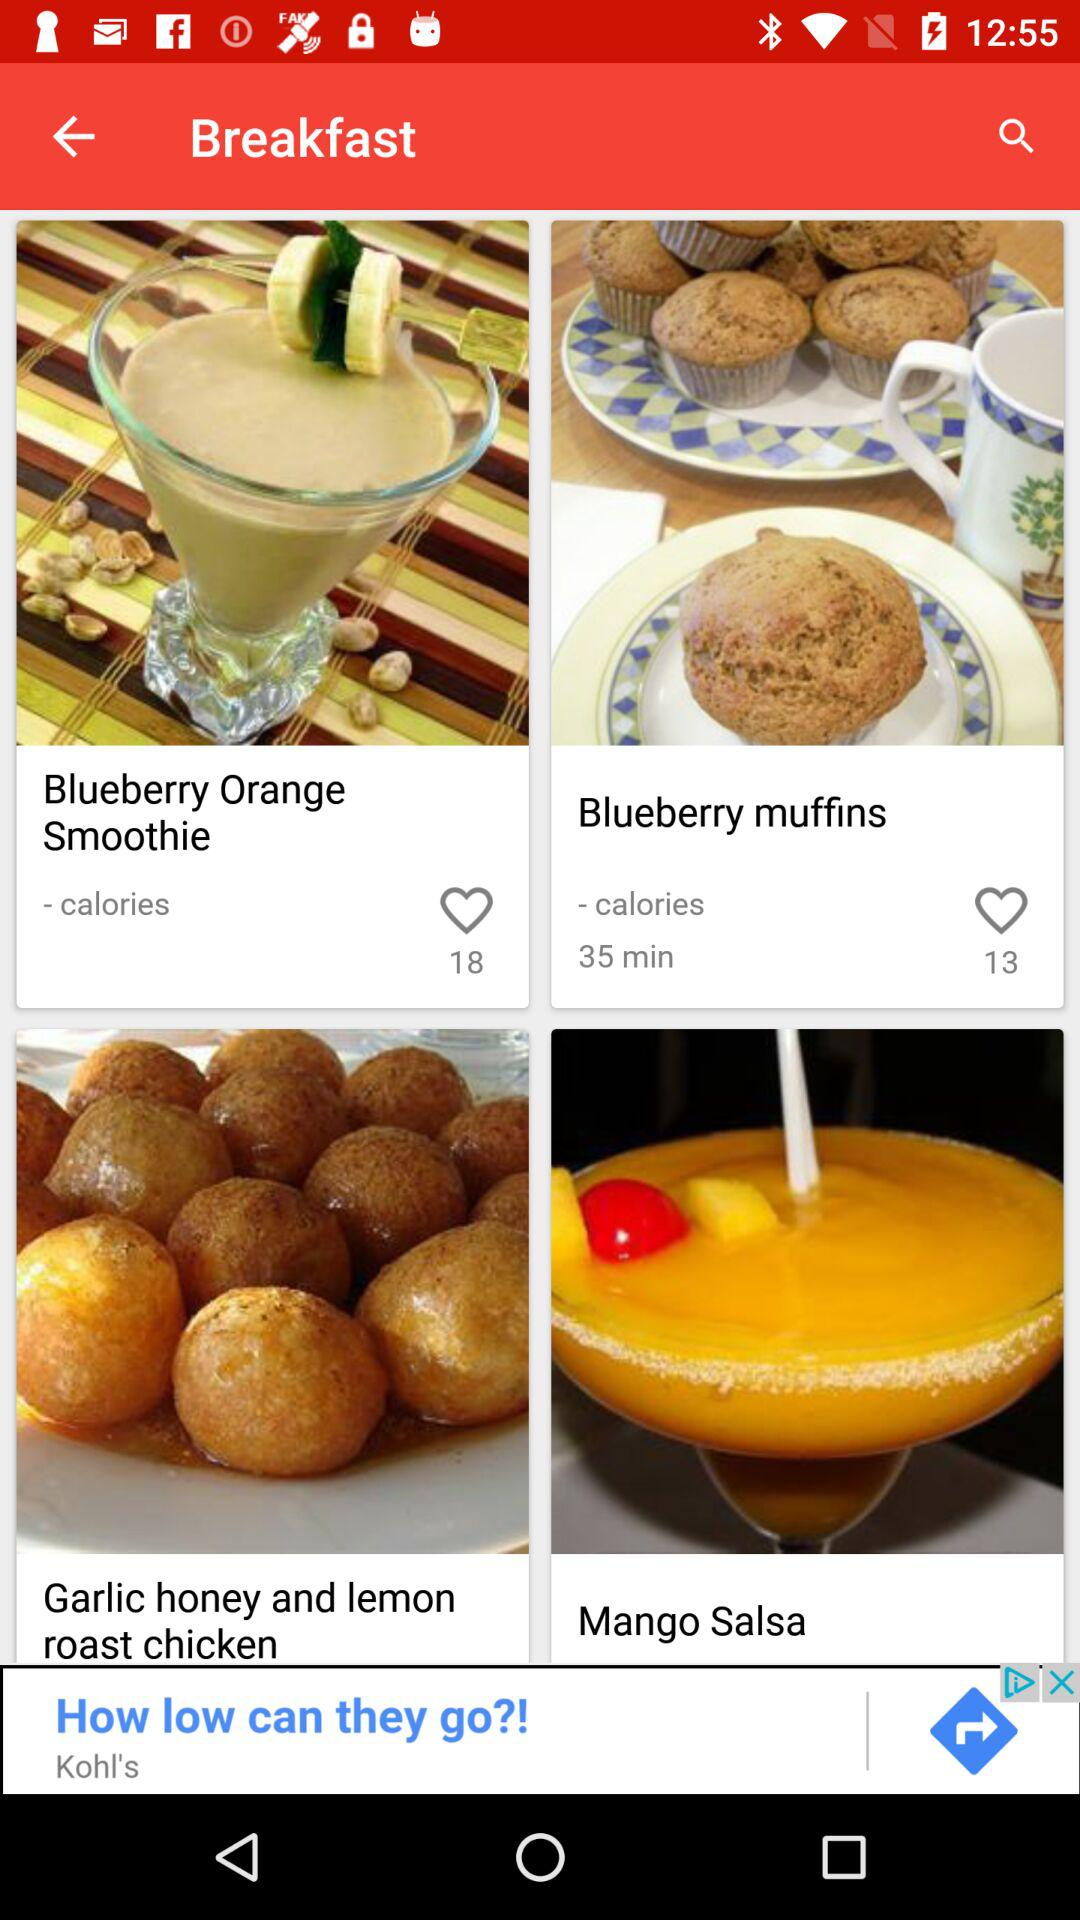What are the different breakfast options available? The different breakfast options available are "Blueberry Orange Smoothie", "Blueberry muffins", "Garlic honey and lemon roast chicken" and "Mango Salsa". 